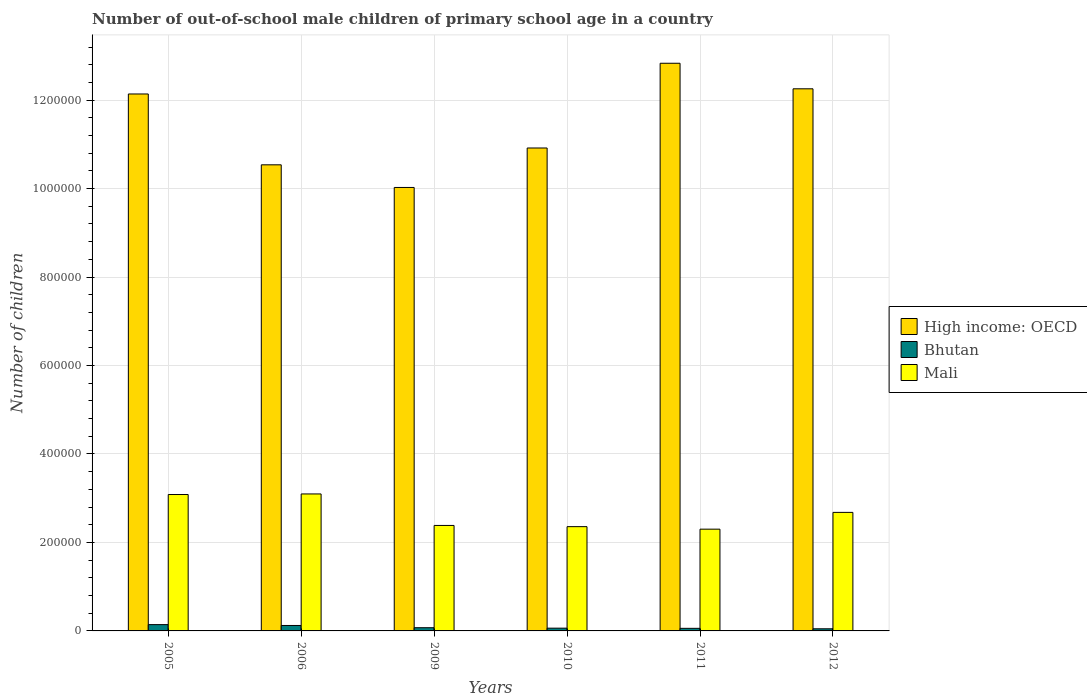How many groups of bars are there?
Your answer should be very brief. 6. How many bars are there on the 4th tick from the left?
Offer a very short reply. 3. What is the number of out-of-school male children in Mali in 2009?
Offer a very short reply. 2.38e+05. Across all years, what is the maximum number of out-of-school male children in Bhutan?
Ensure brevity in your answer.  1.42e+04. Across all years, what is the minimum number of out-of-school male children in Bhutan?
Your answer should be very brief. 4809. In which year was the number of out-of-school male children in High income: OECD minimum?
Your answer should be compact. 2009. What is the total number of out-of-school male children in Mali in the graph?
Your response must be concise. 1.59e+06. What is the difference between the number of out-of-school male children in Bhutan in 2005 and that in 2011?
Ensure brevity in your answer.  8402. What is the difference between the number of out-of-school male children in High income: OECD in 2005 and the number of out-of-school male children in Mali in 2006?
Provide a short and direct response. 9.04e+05. What is the average number of out-of-school male children in High income: OECD per year?
Offer a very short reply. 1.15e+06. In the year 2006, what is the difference between the number of out-of-school male children in High income: OECD and number of out-of-school male children in Bhutan?
Your answer should be compact. 1.04e+06. In how many years, is the number of out-of-school male children in Bhutan greater than 640000?
Offer a terse response. 0. What is the ratio of the number of out-of-school male children in High income: OECD in 2006 to that in 2010?
Your response must be concise. 0.97. Is the number of out-of-school male children in High income: OECD in 2005 less than that in 2010?
Provide a short and direct response. No. Is the difference between the number of out-of-school male children in High income: OECD in 2005 and 2011 greater than the difference between the number of out-of-school male children in Bhutan in 2005 and 2011?
Give a very brief answer. No. What is the difference between the highest and the second highest number of out-of-school male children in High income: OECD?
Offer a very short reply. 5.78e+04. What is the difference between the highest and the lowest number of out-of-school male children in Mali?
Ensure brevity in your answer.  7.96e+04. In how many years, is the number of out-of-school male children in Mali greater than the average number of out-of-school male children in Mali taken over all years?
Your answer should be compact. 3. Is the sum of the number of out-of-school male children in Mali in 2005 and 2012 greater than the maximum number of out-of-school male children in Bhutan across all years?
Your answer should be compact. Yes. What does the 1st bar from the left in 2005 represents?
Ensure brevity in your answer.  High income: OECD. What does the 1st bar from the right in 2005 represents?
Provide a succinct answer. Mali. How many bars are there?
Offer a terse response. 18. Are all the bars in the graph horizontal?
Your response must be concise. No. Are the values on the major ticks of Y-axis written in scientific E-notation?
Provide a succinct answer. No. Does the graph contain grids?
Give a very brief answer. Yes. How many legend labels are there?
Make the answer very short. 3. How are the legend labels stacked?
Provide a succinct answer. Vertical. What is the title of the graph?
Offer a very short reply. Number of out-of-school male children of primary school age in a country. Does "Gabon" appear as one of the legend labels in the graph?
Provide a short and direct response. No. What is the label or title of the X-axis?
Ensure brevity in your answer.  Years. What is the label or title of the Y-axis?
Your response must be concise. Number of children. What is the Number of children in High income: OECD in 2005?
Your answer should be very brief. 1.21e+06. What is the Number of children in Bhutan in 2005?
Make the answer very short. 1.42e+04. What is the Number of children of Mali in 2005?
Your answer should be compact. 3.08e+05. What is the Number of children of High income: OECD in 2006?
Offer a terse response. 1.05e+06. What is the Number of children of Bhutan in 2006?
Give a very brief answer. 1.23e+04. What is the Number of children of Mali in 2006?
Make the answer very short. 3.10e+05. What is the Number of children in High income: OECD in 2009?
Your response must be concise. 1.00e+06. What is the Number of children of Bhutan in 2009?
Provide a short and direct response. 7244. What is the Number of children of Mali in 2009?
Keep it short and to the point. 2.38e+05. What is the Number of children of High income: OECD in 2010?
Make the answer very short. 1.09e+06. What is the Number of children of Bhutan in 2010?
Ensure brevity in your answer.  6228. What is the Number of children of Mali in 2010?
Give a very brief answer. 2.36e+05. What is the Number of children of High income: OECD in 2011?
Offer a very short reply. 1.28e+06. What is the Number of children in Bhutan in 2011?
Your response must be concise. 5845. What is the Number of children in Mali in 2011?
Provide a succinct answer. 2.30e+05. What is the Number of children in High income: OECD in 2012?
Your response must be concise. 1.23e+06. What is the Number of children in Bhutan in 2012?
Ensure brevity in your answer.  4809. What is the Number of children in Mali in 2012?
Make the answer very short. 2.68e+05. Across all years, what is the maximum Number of children in High income: OECD?
Make the answer very short. 1.28e+06. Across all years, what is the maximum Number of children in Bhutan?
Offer a very short reply. 1.42e+04. Across all years, what is the maximum Number of children in Mali?
Make the answer very short. 3.10e+05. Across all years, what is the minimum Number of children of High income: OECD?
Make the answer very short. 1.00e+06. Across all years, what is the minimum Number of children in Bhutan?
Your response must be concise. 4809. Across all years, what is the minimum Number of children of Mali?
Make the answer very short. 2.30e+05. What is the total Number of children in High income: OECD in the graph?
Your response must be concise. 6.87e+06. What is the total Number of children in Bhutan in the graph?
Give a very brief answer. 5.07e+04. What is the total Number of children in Mali in the graph?
Make the answer very short. 1.59e+06. What is the difference between the Number of children of High income: OECD in 2005 and that in 2006?
Make the answer very short. 1.60e+05. What is the difference between the Number of children in Bhutan in 2005 and that in 2006?
Your response must be concise. 1950. What is the difference between the Number of children of Mali in 2005 and that in 2006?
Provide a succinct answer. -1292. What is the difference between the Number of children of High income: OECD in 2005 and that in 2009?
Keep it short and to the point. 2.11e+05. What is the difference between the Number of children of Bhutan in 2005 and that in 2009?
Ensure brevity in your answer.  7003. What is the difference between the Number of children in Mali in 2005 and that in 2009?
Your response must be concise. 6.99e+04. What is the difference between the Number of children of High income: OECD in 2005 and that in 2010?
Provide a succinct answer. 1.22e+05. What is the difference between the Number of children of Bhutan in 2005 and that in 2010?
Provide a short and direct response. 8019. What is the difference between the Number of children of Mali in 2005 and that in 2010?
Your response must be concise. 7.26e+04. What is the difference between the Number of children in High income: OECD in 2005 and that in 2011?
Your answer should be very brief. -6.94e+04. What is the difference between the Number of children of Bhutan in 2005 and that in 2011?
Offer a terse response. 8402. What is the difference between the Number of children in Mali in 2005 and that in 2011?
Offer a terse response. 7.83e+04. What is the difference between the Number of children in High income: OECD in 2005 and that in 2012?
Your response must be concise. -1.17e+04. What is the difference between the Number of children of Bhutan in 2005 and that in 2012?
Give a very brief answer. 9438. What is the difference between the Number of children in Mali in 2005 and that in 2012?
Your answer should be compact. 4.04e+04. What is the difference between the Number of children in High income: OECD in 2006 and that in 2009?
Provide a succinct answer. 5.12e+04. What is the difference between the Number of children in Bhutan in 2006 and that in 2009?
Keep it short and to the point. 5053. What is the difference between the Number of children in Mali in 2006 and that in 2009?
Your answer should be compact. 7.12e+04. What is the difference between the Number of children in High income: OECD in 2006 and that in 2010?
Your response must be concise. -3.80e+04. What is the difference between the Number of children of Bhutan in 2006 and that in 2010?
Offer a very short reply. 6069. What is the difference between the Number of children of Mali in 2006 and that in 2010?
Keep it short and to the point. 7.39e+04. What is the difference between the Number of children in High income: OECD in 2006 and that in 2011?
Make the answer very short. -2.30e+05. What is the difference between the Number of children in Bhutan in 2006 and that in 2011?
Make the answer very short. 6452. What is the difference between the Number of children in Mali in 2006 and that in 2011?
Make the answer very short. 7.96e+04. What is the difference between the Number of children of High income: OECD in 2006 and that in 2012?
Offer a very short reply. -1.72e+05. What is the difference between the Number of children of Bhutan in 2006 and that in 2012?
Offer a terse response. 7488. What is the difference between the Number of children of Mali in 2006 and that in 2012?
Your answer should be very brief. 4.17e+04. What is the difference between the Number of children of High income: OECD in 2009 and that in 2010?
Your response must be concise. -8.92e+04. What is the difference between the Number of children of Bhutan in 2009 and that in 2010?
Ensure brevity in your answer.  1016. What is the difference between the Number of children in Mali in 2009 and that in 2010?
Your answer should be very brief. 2689. What is the difference between the Number of children of High income: OECD in 2009 and that in 2011?
Provide a short and direct response. -2.81e+05. What is the difference between the Number of children in Bhutan in 2009 and that in 2011?
Provide a succinct answer. 1399. What is the difference between the Number of children of Mali in 2009 and that in 2011?
Offer a very short reply. 8394. What is the difference between the Number of children in High income: OECD in 2009 and that in 2012?
Your answer should be very brief. -2.23e+05. What is the difference between the Number of children of Bhutan in 2009 and that in 2012?
Your answer should be very brief. 2435. What is the difference between the Number of children in Mali in 2009 and that in 2012?
Offer a very short reply. -2.95e+04. What is the difference between the Number of children of High income: OECD in 2010 and that in 2011?
Your answer should be compact. -1.92e+05. What is the difference between the Number of children of Bhutan in 2010 and that in 2011?
Offer a very short reply. 383. What is the difference between the Number of children of Mali in 2010 and that in 2011?
Provide a succinct answer. 5705. What is the difference between the Number of children in High income: OECD in 2010 and that in 2012?
Provide a short and direct response. -1.34e+05. What is the difference between the Number of children of Bhutan in 2010 and that in 2012?
Provide a succinct answer. 1419. What is the difference between the Number of children in Mali in 2010 and that in 2012?
Provide a short and direct response. -3.22e+04. What is the difference between the Number of children in High income: OECD in 2011 and that in 2012?
Offer a very short reply. 5.78e+04. What is the difference between the Number of children in Bhutan in 2011 and that in 2012?
Keep it short and to the point. 1036. What is the difference between the Number of children in Mali in 2011 and that in 2012?
Make the answer very short. -3.79e+04. What is the difference between the Number of children of High income: OECD in 2005 and the Number of children of Bhutan in 2006?
Offer a terse response. 1.20e+06. What is the difference between the Number of children in High income: OECD in 2005 and the Number of children in Mali in 2006?
Provide a short and direct response. 9.04e+05. What is the difference between the Number of children of Bhutan in 2005 and the Number of children of Mali in 2006?
Your answer should be very brief. -2.95e+05. What is the difference between the Number of children of High income: OECD in 2005 and the Number of children of Bhutan in 2009?
Give a very brief answer. 1.21e+06. What is the difference between the Number of children in High income: OECD in 2005 and the Number of children in Mali in 2009?
Keep it short and to the point. 9.75e+05. What is the difference between the Number of children of Bhutan in 2005 and the Number of children of Mali in 2009?
Keep it short and to the point. -2.24e+05. What is the difference between the Number of children of High income: OECD in 2005 and the Number of children of Bhutan in 2010?
Offer a terse response. 1.21e+06. What is the difference between the Number of children in High income: OECD in 2005 and the Number of children in Mali in 2010?
Ensure brevity in your answer.  9.78e+05. What is the difference between the Number of children in Bhutan in 2005 and the Number of children in Mali in 2010?
Offer a very short reply. -2.22e+05. What is the difference between the Number of children in High income: OECD in 2005 and the Number of children in Bhutan in 2011?
Your answer should be compact. 1.21e+06. What is the difference between the Number of children in High income: OECD in 2005 and the Number of children in Mali in 2011?
Provide a short and direct response. 9.84e+05. What is the difference between the Number of children in Bhutan in 2005 and the Number of children in Mali in 2011?
Provide a short and direct response. -2.16e+05. What is the difference between the Number of children in High income: OECD in 2005 and the Number of children in Bhutan in 2012?
Offer a very short reply. 1.21e+06. What is the difference between the Number of children in High income: OECD in 2005 and the Number of children in Mali in 2012?
Offer a very short reply. 9.46e+05. What is the difference between the Number of children in Bhutan in 2005 and the Number of children in Mali in 2012?
Make the answer very short. -2.54e+05. What is the difference between the Number of children of High income: OECD in 2006 and the Number of children of Bhutan in 2009?
Offer a very short reply. 1.05e+06. What is the difference between the Number of children of High income: OECD in 2006 and the Number of children of Mali in 2009?
Keep it short and to the point. 8.15e+05. What is the difference between the Number of children in Bhutan in 2006 and the Number of children in Mali in 2009?
Your response must be concise. -2.26e+05. What is the difference between the Number of children in High income: OECD in 2006 and the Number of children in Bhutan in 2010?
Offer a very short reply. 1.05e+06. What is the difference between the Number of children of High income: OECD in 2006 and the Number of children of Mali in 2010?
Your response must be concise. 8.18e+05. What is the difference between the Number of children in Bhutan in 2006 and the Number of children in Mali in 2010?
Your answer should be compact. -2.23e+05. What is the difference between the Number of children of High income: OECD in 2006 and the Number of children of Bhutan in 2011?
Keep it short and to the point. 1.05e+06. What is the difference between the Number of children of High income: OECD in 2006 and the Number of children of Mali in 2011?
Offer a terse response. 8.24e+05. What is the difference between the Number of children in Bhutan in 2006 and the Number of children in Mali in 2011?
Offer a terse response. -2.18e+05. What is the difference between the Number of children of High income: OECD in 2006 and the Number of children of Bhutan in 2012?
Your response must be concise. 1.05e+06. What is the difference between the Number of children in High income: OECD in 2006 and the Number of children in Mali in 2012?
Ensure brevity in your answer.  7.86e+05. What is the difference between the Number of children in Bhutan in 2006 and the Number of children in Mali in 2012?
Offer a terse response. -2.56e+05. What is the difference between the Number of children of High income: OECD in 2009 and the Number of children of Bhutan in 2010?
Your response must be concise. 9.96e+05. What is the difference between the Number of children in High income: OECD in 2009 and the Number of children in Mali in 2010?
Ensure brevity in your answer.  7.67e+05. What is the difference between the Number of children of Bhutan in 2009 and the Number of children of Mali in 2010?
Give a very brief answer. -2.29e+05. What is the difference between the Number of children of High income: OECD in 2009 and the Number of children of Bhutan in 2011?
Make the answer very short. 9.97e+05. What is the difference between the Number of children in High income: OECD in 2009 and the Number of children in Mali in 2011?
Ensure brevity in your answer.  7.73e+05. What is the difference between the Number of children in Bhutan in 2009 and the Number of children in Mali in 2011?
Ensure brevity in your answer.  -2.23e+05. What is the difference between the Number of children of High income: OECD in 2009 and the Number of children of Bhutan in 2012?
Provide a succinct answer. 9.98e+05. What is the difference between the Number of children in High income: OECD in 2009 and the Number of children in Mali in 2012?
Your response must be concise. 7.35e+05. What is the difference between the Number of children in Bhutan in 2009 and the Number of children in Mali in 2012?
Your answer should be very brief. -2.61e+05. What is the difference between the Number of children of High income: OECD in 2010 and the Number of children of Bhutan in 2011?
Your response must be concise. 1.09e+06. What is the difference between the Number of children of High income: OECD in 2010 and the Number of children of Mali in 2011?
Your answer should be very brief. 8.62e+05. What is the difference between the Number of children of Bhutan in 2010 and the Number of children of Mali in 2011?
Offer a terse response. -2.24e+05. What is the difference between the Number of children in High income: OECD in 2010 and the Number of children in Bhutan in 2012?
Make the answer very short. 1.09e+06. What is the difference between the Number of children of High income: OECD in 2010 and the Number of children of Mali in 2012?
Provide a succinct answer. 8.24e+05. What is the difference between the Number of children of Bhutan in 2010 and the Number of children of Mali in 2012?
Offer a terse response. -2.62e+05. What is the difference between the Number of children of High income: OECD in 2011 and the Number of children of Bhutan in 2012?
Ensure brevity in your answer.  1.28e+06. What is the difference between the Number of children in High income: OECD in 2011 and the Number of children in Mali in 2012?
Offer a very short reply. 1.02e+06. What is the difference between the Number of children in Bhutan in 2011 and the Number of children in Mali in 2012?
Ensure brevity in your answer.  -2.62e+05. What is the average Number of children of High income: OECD per year?
Offer a very short reply. 1.15e+06. What is the average Number of children in Bhutan per year?
Your response must be concise. 8445. What is the average Number of children in Mali per year?
Provide a short and direct response. 2.65e+05. In the year 2005, what is the difference between the Number of children in High income: OECD and Number of children in Bhutan?
Offer a terse response. 1.20e+06. In the year 2005, what is the difference between the Number of children in High income: OECD and Number of children in Mali?
Offer a very short reply. 9.06e+05. In the year 2005, what is the difference between the Number of children of Bhutan and Number of children of Mali?
Provide a short and direct response. -2.94e+05. In the year 2006, what is the difference between the Number of children of High income: OECD and Number of children of Bhutan?
Give a very brief answer. 1.04e+06. In the year 2006, what is the difference between the Number of children of High income: OECD and Number of children of Mali?
Ensure brevity in your answer.  7.44e+05. In the year 2006, what is the difference between the Number of children in Bhutan and Number of children in Mali?
Your response must be concise. -2.97e+05. In the year 2009, what is the difference between the Number of children in High income: OECD and Number of children in Bhutan?
Your answer should be very brief. 9.95e+05. In the year 2009, what is the difference between the Number of children in High income: OECD and Number of children in Mali?
Provide a succinct answer. 7.64e+05. In the year 2009, what is the difference between the Number of children of Bhutan and Number of children of Mali?
Make the answer very short. -2.31e+05. In the year 2010, what is the difference between the Number of children of High income: OECD and Number of children of Bhutan?
Provide a succinct answer. 1.09e+06. In the year 2010, what is the difference between the Number of children in High income: OECD and Number of children in Mali?
Your answer should be compact. 8.56e+05. In the year 2010, what is the difference between the Number of children in Bhutan and Number of children in Mali?
Provide a succinct answer. -2.30e+05. In the year 2011, what is the difference between the Number of children of High income: OECD and Number of children of Bhutan?
Offer a very short reply. 1.28e+06. In the year 2011, what is the difference between the Number of children in High income: OECD and Number of children in Mali?
Offer a very short reply. 1.05e+06. In the year 2011, what is the difference between the Number of children in Bhutan and Number of children in Mali?
Your response must be concise. -2.24e+05. In the year 2012, what is the difference between the Number of children of High income: OECD and Number of children of Bhutan?
Provide a succinct answer. 1.22e+06. In the year 2012, what is the difference between the Number of children of High income: OECD and Number of children of Mali?
Provide a short and direct response. 9.58e+05. In the year 2012, what is the difference between the Number of children in Bhutan and Number of children in Mali?
Your answer should be very brief. -2.63e+05. What is the ratio of the Number of children of High income: OECD in 2005 to that in 2006?
Make the answer very short. 1.15. What is the ratio of the Number of children in Bhutan in 2005 to that in 2006?
Provide a short and direct response. 1.16. What is the ratio of the Number of children of High income: OECD in 2005 to that in 2009?
Your response must be concise. 1.21. What is the ratio of the Number of children of Bhutan in 2005 to that in 2009?
Provide a succinct answer. 1.97. What is the ratio of the Number of children of Mali in 2005 to that in 2009?
Your answer should be very brief. 1.29. What is the ratio of the Number of children of High income: OECD in 2005 to that in 2010?
Offer a very short reply. 1.11. What is the ratio of the Number of children of Bhutan in 2005 to that in 2010?
Ensure brevity in your answer.  2.29. What is the ratio of the Number of children of Mali in 2005 to that in 2010?
Ensure brevity in your answer.  1.31. What is the ratio of the Number of children in High income: OECD in 2005 to that in 2011?
Ensure brevity in your answer.  0.95. What is the ratio of the Number of children of Bhutan in 2005 to that in 2011?
Provide a succinct answer. 2.44. What is the ratio of the Number of children of Mali in 2005 to that in 2011?
Provide a short and direct response. 1.34. What is the ratio of the Number of children of Bhutan in 2005 to that in 2012?
Provide a short and direct response. 2.96. What is the ratio of the Number of children of Mali in 2005 to that in 2012?
Keep it short and to the point. 1.15. What is the ratio of the Number of children in High income: OECD in 2006 to that in 2009?
Keep it short and to the point. 1.05. What is the ratio of the Number of children of Bhutan in 2006 to that in 2009?
Provide a succinct answer. 1.7. What is the ratio of the Number of children in Mali in 2006 to that in 2009?
Make the answer very short. 1.3. What is the ratio of the Number of children of High income: OECD in 2006 to that in 2010?
Give a very brief answer. 0.97. What is the ratio of the Number of children of Bhutan in 2006 to that in 2010?
Your response must be concise. 1.97. What is the ratio of the Number of children in Mali in 2006 to that in 2010?
Provide a short and direct response. 1.31. What is the ratio of the Number of children of High income: OECD in 2006 to that in 2011?
Make the answer very short. 0.82. What is the ratio of the Number of children of Bhutan in 2006 to that in 2011?
Keep it short and to the point. 2.1. What is the ratio of the Number of children of Mali in 2006 to that in 2011?
Your response must be concise. 1.35. What is the ratio of the Number of children in High income: OECD in 2006 to that in 2012?
Your answer should be very brief. 0.86. What is the ratio of the Number of children of Bhutan in 2006 to that in 2012?
Offer a terse response. 2.56. What is the ratio of the Number of children of Mali in 2006 to that in 2012?
Provide a succinct answer. 1.16. What is the ratio of the Number of children in High income: OECD in 2009 to that in 2010?
Provide a succinct answer. 0.92. What is the ratio of the Number of children in Bhutan in 2009 to that in 2010?
Keep it short and to the point. 1.16. What is the ratio of the Number of children in Mali in 2009 to that in 2010?
Offer a terse response. 1.01. What is the ratio of the Number of children in High income: OECD in 2009 to that in 2011?
Offer a terse response. 0.78. What is the ratio of the Number of children in Bhutan in 2009 to that in 2011?
Provide a succinct answer. 1.24. What is the ratio of the Number of children of Mali in 2009 to that in 2011?
Your response must be concise. 1.04. What is the ratio of the Number of children in High income: OECD in 2009 to that in 2012?
Offer a very short reply. 0.82. What is the ratio of the Number of children in Bhutan in 2009 to that in 2012?
Provide a short and direct response. 1.51. What is the ratio of the Number of children of Mali in 2009 to that in 2012?
Offer a very short reply. 0.89. What is the ratio of the Number of children of High income: OECD in 2010 to that in 2011?
Your answer should be very brief. 0.85. What is the ratio of the Number of children of Bhutan in 2010 to that in 2011?
Make the answer very short. 1.07. What is the ratio of the Number of children in Mali in 2010 to that in 2011?
Provide a succinct answer. 1.02. What is the ratio of the Number of children of High income: OECD in 2010 to that in 2012?
Offer a very short reply. 0.89. What is the ratio of the Number of children in Bhutan in 2010 to that in 2012?
Provide a succinct answer. 1.3. What is the ratio of the Number of children of Mali in 2010 to that in 2012?
Your answer should be compact. 0.88. What is the ratio of the Number of children of High income: OECD in 2011 to that in 2012?
Your answer should be very brief. 1.05. What is the ratio of the Number of children of Bhutan in 2011 to that in 2012?
Make the answer very short. 1.22. What is the ratio of the Number of children of Mali in 2011 to that in 2012?
Provide a succinct answer. 0.86. What is the difference between the highest and the second highest Number of children of High income: OECD?
Make the answer very short. 5.78e+04. What is the difference between the highest and the second highest Number of children of Bhutan?
Keep it short and to the point. 1950. What is the difference between the highest and the second highest Number of children of Mali?
Your response must be concise. 1292. What is the difference between the highest and the lowest Number of children in High income: OECD?
Your response must be concise. 2.81e+05. What is the difference between the highest and the lowest Number of children of Bhutan?
Offer a terse response. 9438. What is the difference between the highest and the lowest Number of children in Mali?
Keep it short and to the point. 7.96e+04. 